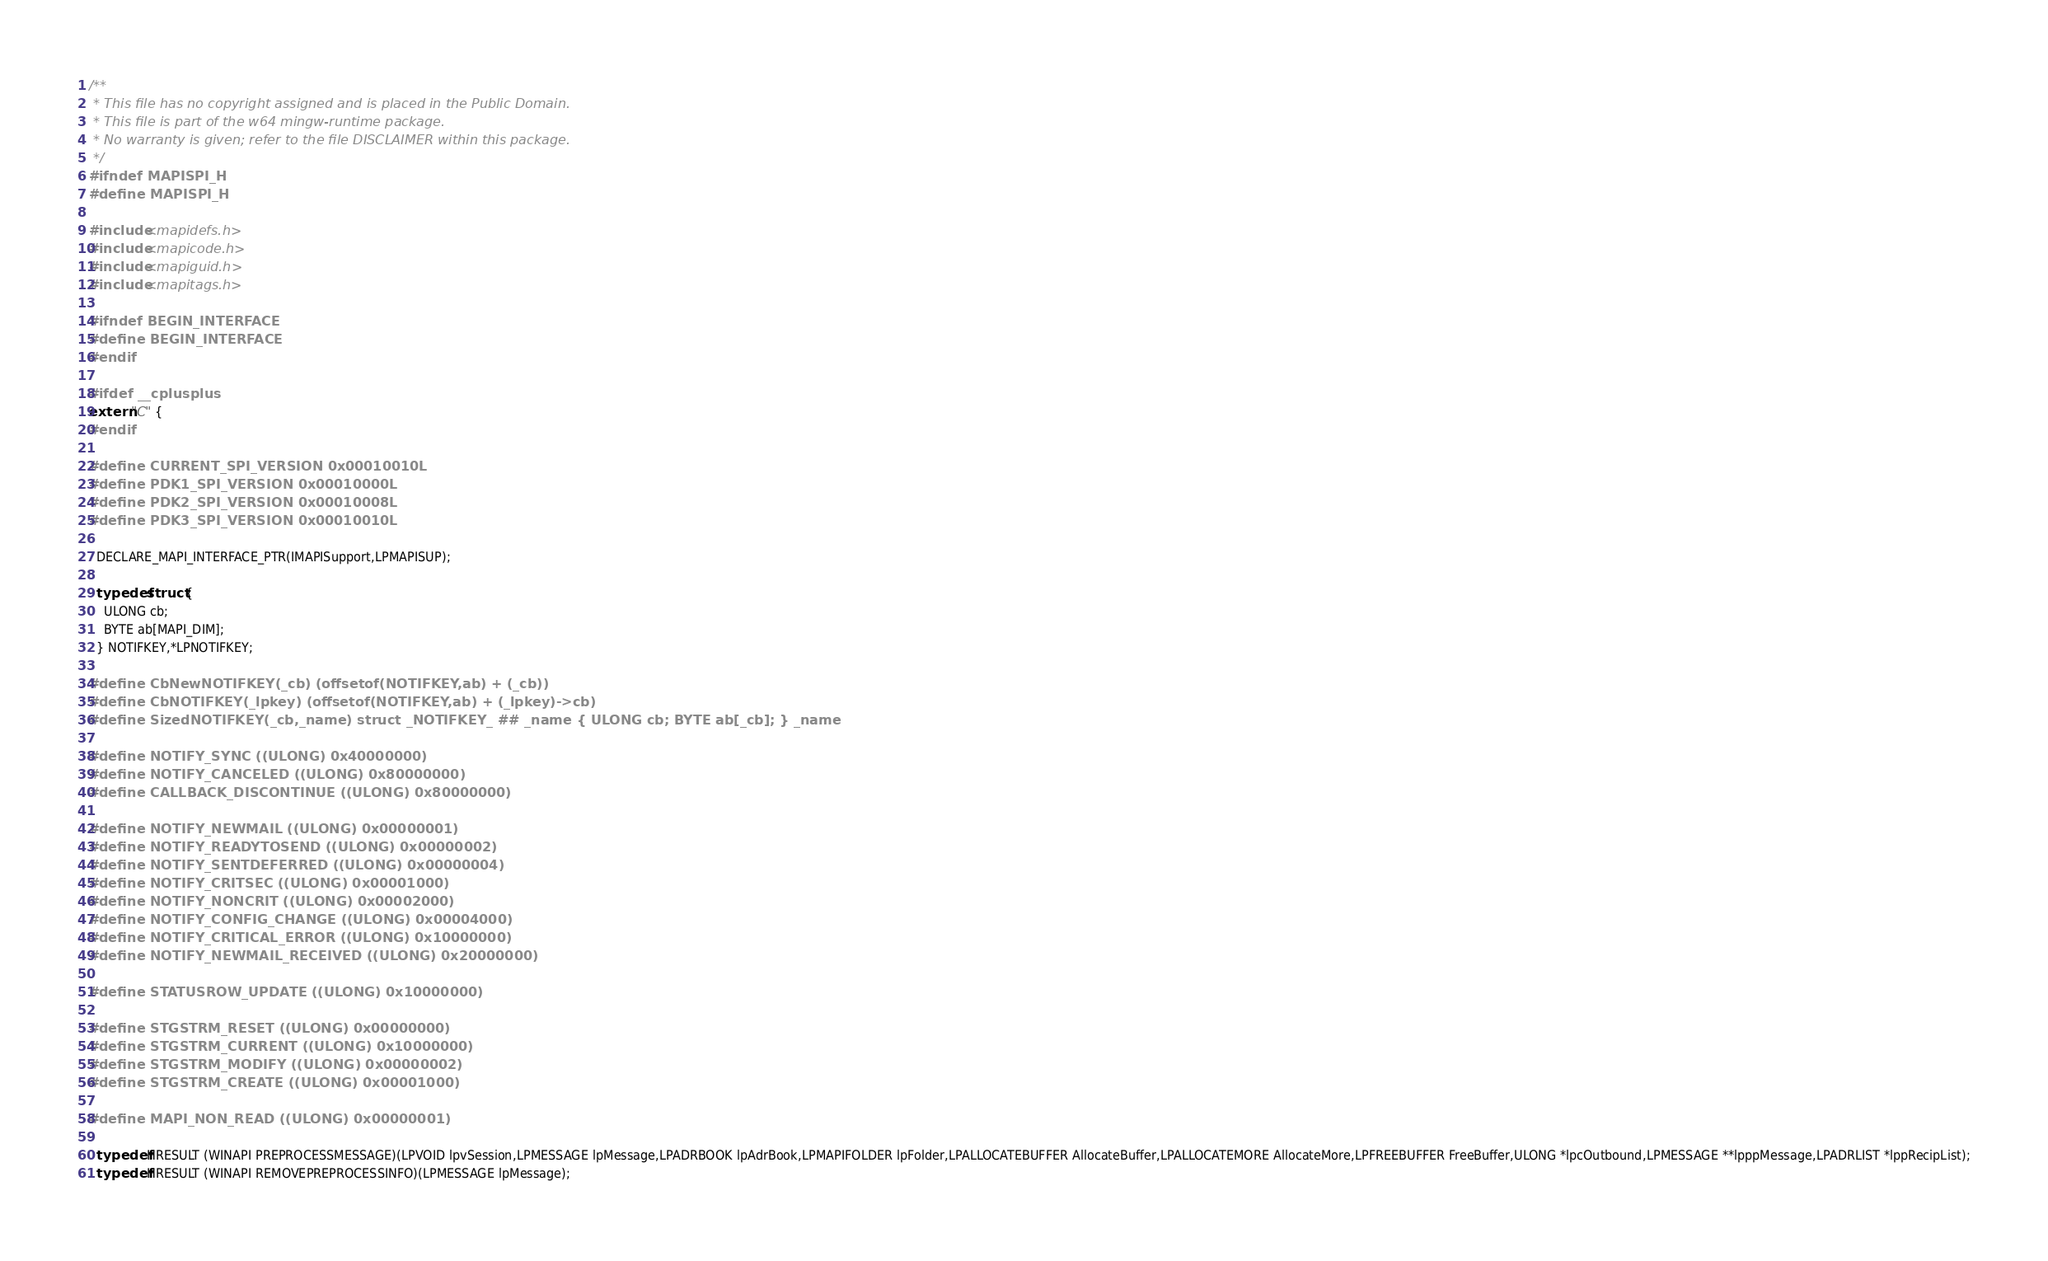<code> <loc_0><loc_0><loc_500><loc_500><_C_>/**
 * This file has no copyright assigned and is placed in the Public Domain.
 * This file is part of the w64 mingw-runtime package.
 * No warranty is given; refer to the file DISCLAIMER within this package.
 */
#ifndef MAPISPI_H
#define MAPISPI_H

#include <mapidefs.h>
#include <mapicode.h>
#include <mapiguid.h>
#include <mapitags.h>

#ifndef BEGIN_INTERFACE
#define BEGIN_INTERFACE
#endif

#ifdef __cplusplus
extern "C" {
#endif

#define CURRENT_SPI_VERSION 0x00010010L
#define PDK1_SPI_VERSION 0x00010000L
#define PDK2_SPI_VERSION 0x00010008L
#define PDK3_SPI_VERSION 0x00010010L

  DECLARE_MAPI_INTERFACE_PTR(IMAPISupport,LPMAPISUP);

  typedef struct {
    ULONG cb;
    BYTE ab[MAPI_DIM];
  } NOTIFKEY,*LPNOTIFKEY;

#define CbNewNOTIFKEY(_cb) (offsetof(NOTIFKEY,ab) + (_cb))
#define CbNOTIFKEY(_lpkey) (offsetof(NOTIFKEY,ab) + (_lpkey)->cb)
#define SizedNOTIFKEY(_cb,_name) struct _NOTIFKEY_ ## _name { ULONG cb; BYTE ab[_cb]; } _name

#define NOTIFY_SYNC ((ULONG) 0x40000000)
#define NOTIFY_CANCELED ((ULONG) 0x80000000)
#define CALLBACK_DISCONTINUE ((ULONG) 0x80000000)

#define NOTIFY_NEWMAIL ((ULONG) 0x00000001)
#define NOTIFY_READYTOSEND ((ULONG) 0x00000002)
#define NOTIFY_SENTDEFERRED ((ULONG) 0x00000004)
#define NOTIFY_CRITSEC ((ULONG) 0x00001000)
#define NOTIFY_NONCRIT ((ULONG) 0x00002000)
#define NOTIFY_CONFIG_CHANGE ((ULONG) 0x00004000)
#define NOTIFY_CRITICAL_ERROR ((ULONG) 0x10000000)
#define NOTIFY_NEWMAIL_RECEIVED ((ULONG) 0x20000000)

#define STATUSROW_UPDATE ((ULONG) 0x10000000)

#define STGSTRM_RESET ((ULONG) 0x00000000)
#define STGSTRM_CURRENT ((ULONG) 0x10000000)
#define STGSTRM_MODIFY ((ULONG) 0x00000002)
#define STGSTRM_CREATE ((ULONG) 0x00001000)

#define MAPI_NON_READ ((ULONG) 0x00000001)

  typedef HRESULT (WINAPI PREPROCESSMESSAGE)(LPVOID lpvSession,LPMESSAGE lpMessage,LPADRBOOK lpAdrBook,LPMAPIFOLDER lpFolder,LPALLOCATEBUFFER AllocateBuffer,LPALLOCATEMORE AllocateMore,LPFREEBUFFER FreeBuffer,ULONG *lpcOutbound,LPMESSAGE **lpppMessage,LPADRLIST *lppRecipList);
  typedef HRESULT (WINAPI REMOVEPREPROCESSINFO)(LPMESSAGE lpMessage);
</code> 